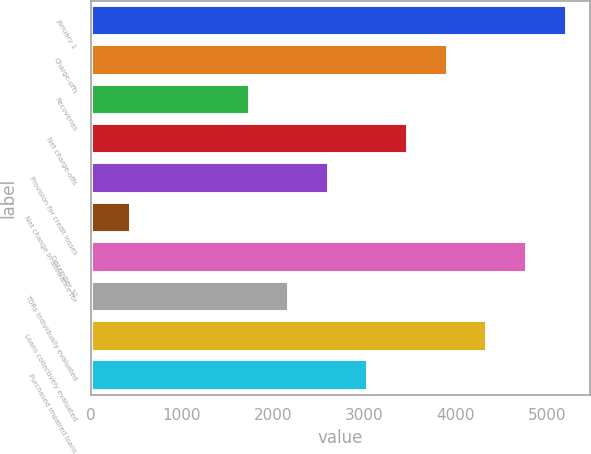Convert chart to OTSL. <chart><loc_0><loc_0><loc_500><loc_500><bar_chart><fcel>January 1<fcel>Charge-offs<fcel>Recoveries<fcel>Net charge-offs<fcel>Provision for credit losses<fcel>Net change in allowance for<fcel>December 31<fcel>TDRs individually evaluated<fcel>Loans collectively evaluated<fcel>Purchased impaired loans<nl><fcel>5215.93<fcel>3912.49<fcel>1740.09<fcel>3478.01<fcel>2609.05<fcel>436.65<fcel>4781.45<fcel>2174.57<fcel>4346.97<fcel>3043.53<nl></chart> 